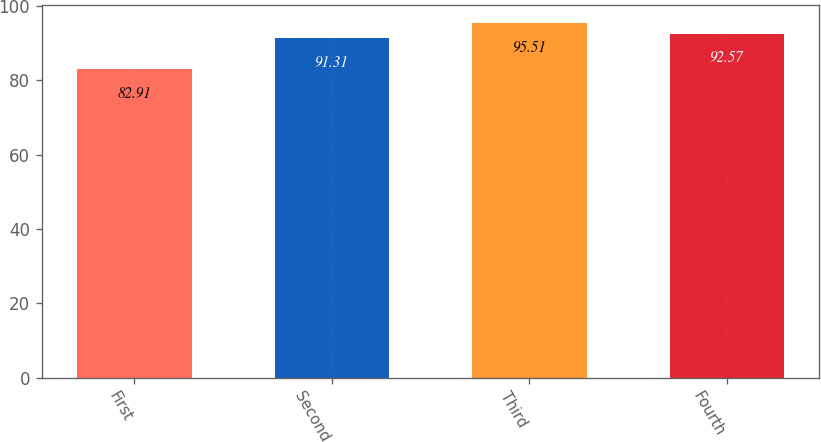Convert chart to OTSL. <chart><loc_0><loc_0><loc_500><loc_500><bar_chart><fcel>First<fcel>Second<fcel>Third<fcel>Fourth<nl><fcel>82.91<fcel>91.31<fcel>95.51<fcel>92.57<nl></chart> 